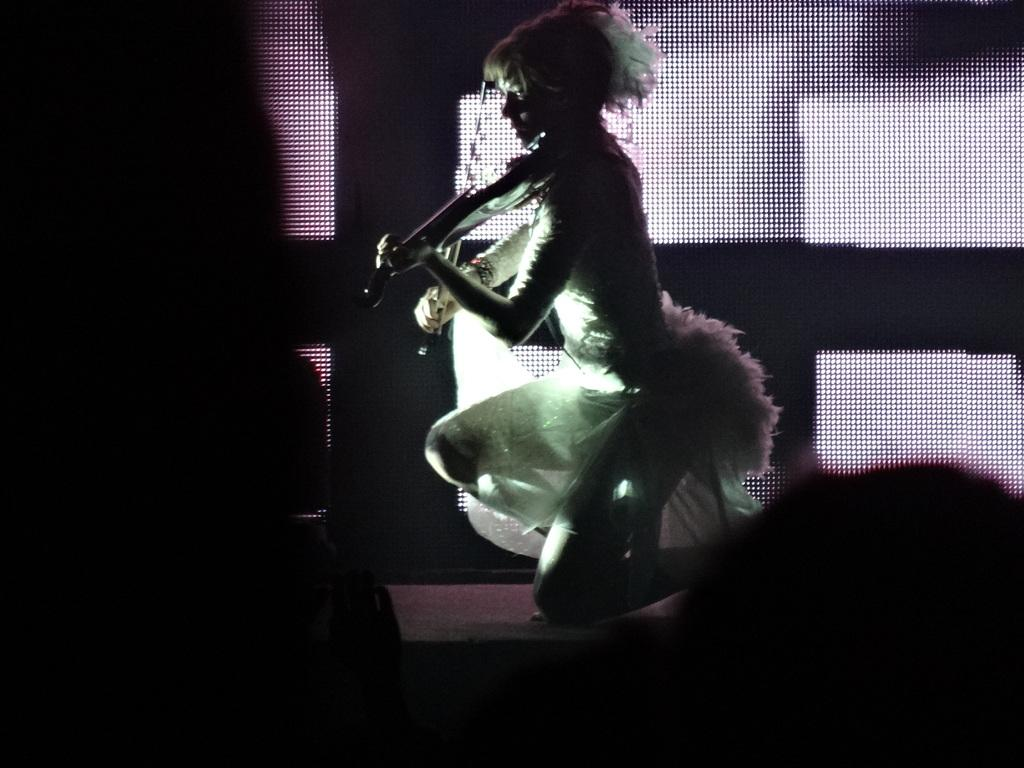What is the overall tone or lighting of the image? The image is dark. Who is the main subject in the image? There is a woman in the image. What is the woman doing in the image? The woman is playing a musical instrument. What is the name of the pan that the woman is using to play the musical instrument? There is no pan present in the image, and the woman is not using any pan to play the musical instrument. 